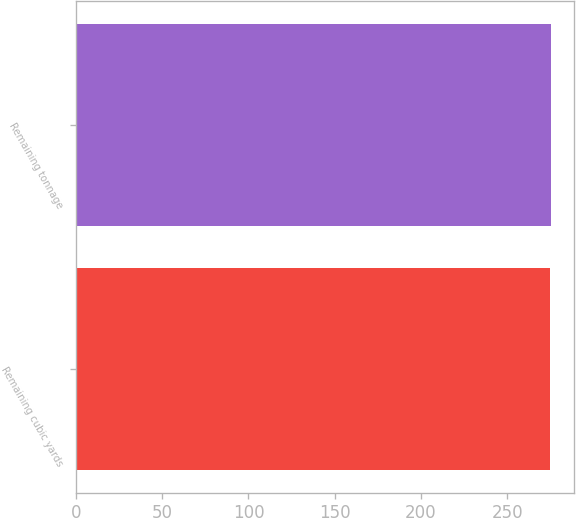<chart> <loc_0><loc_0><loc_500><loc_500><bar_chart><fcel>Remaining cubic yards<fcel>Remaining tonnage<nl><fcel>275<fcel>275.1<nl></chart> 